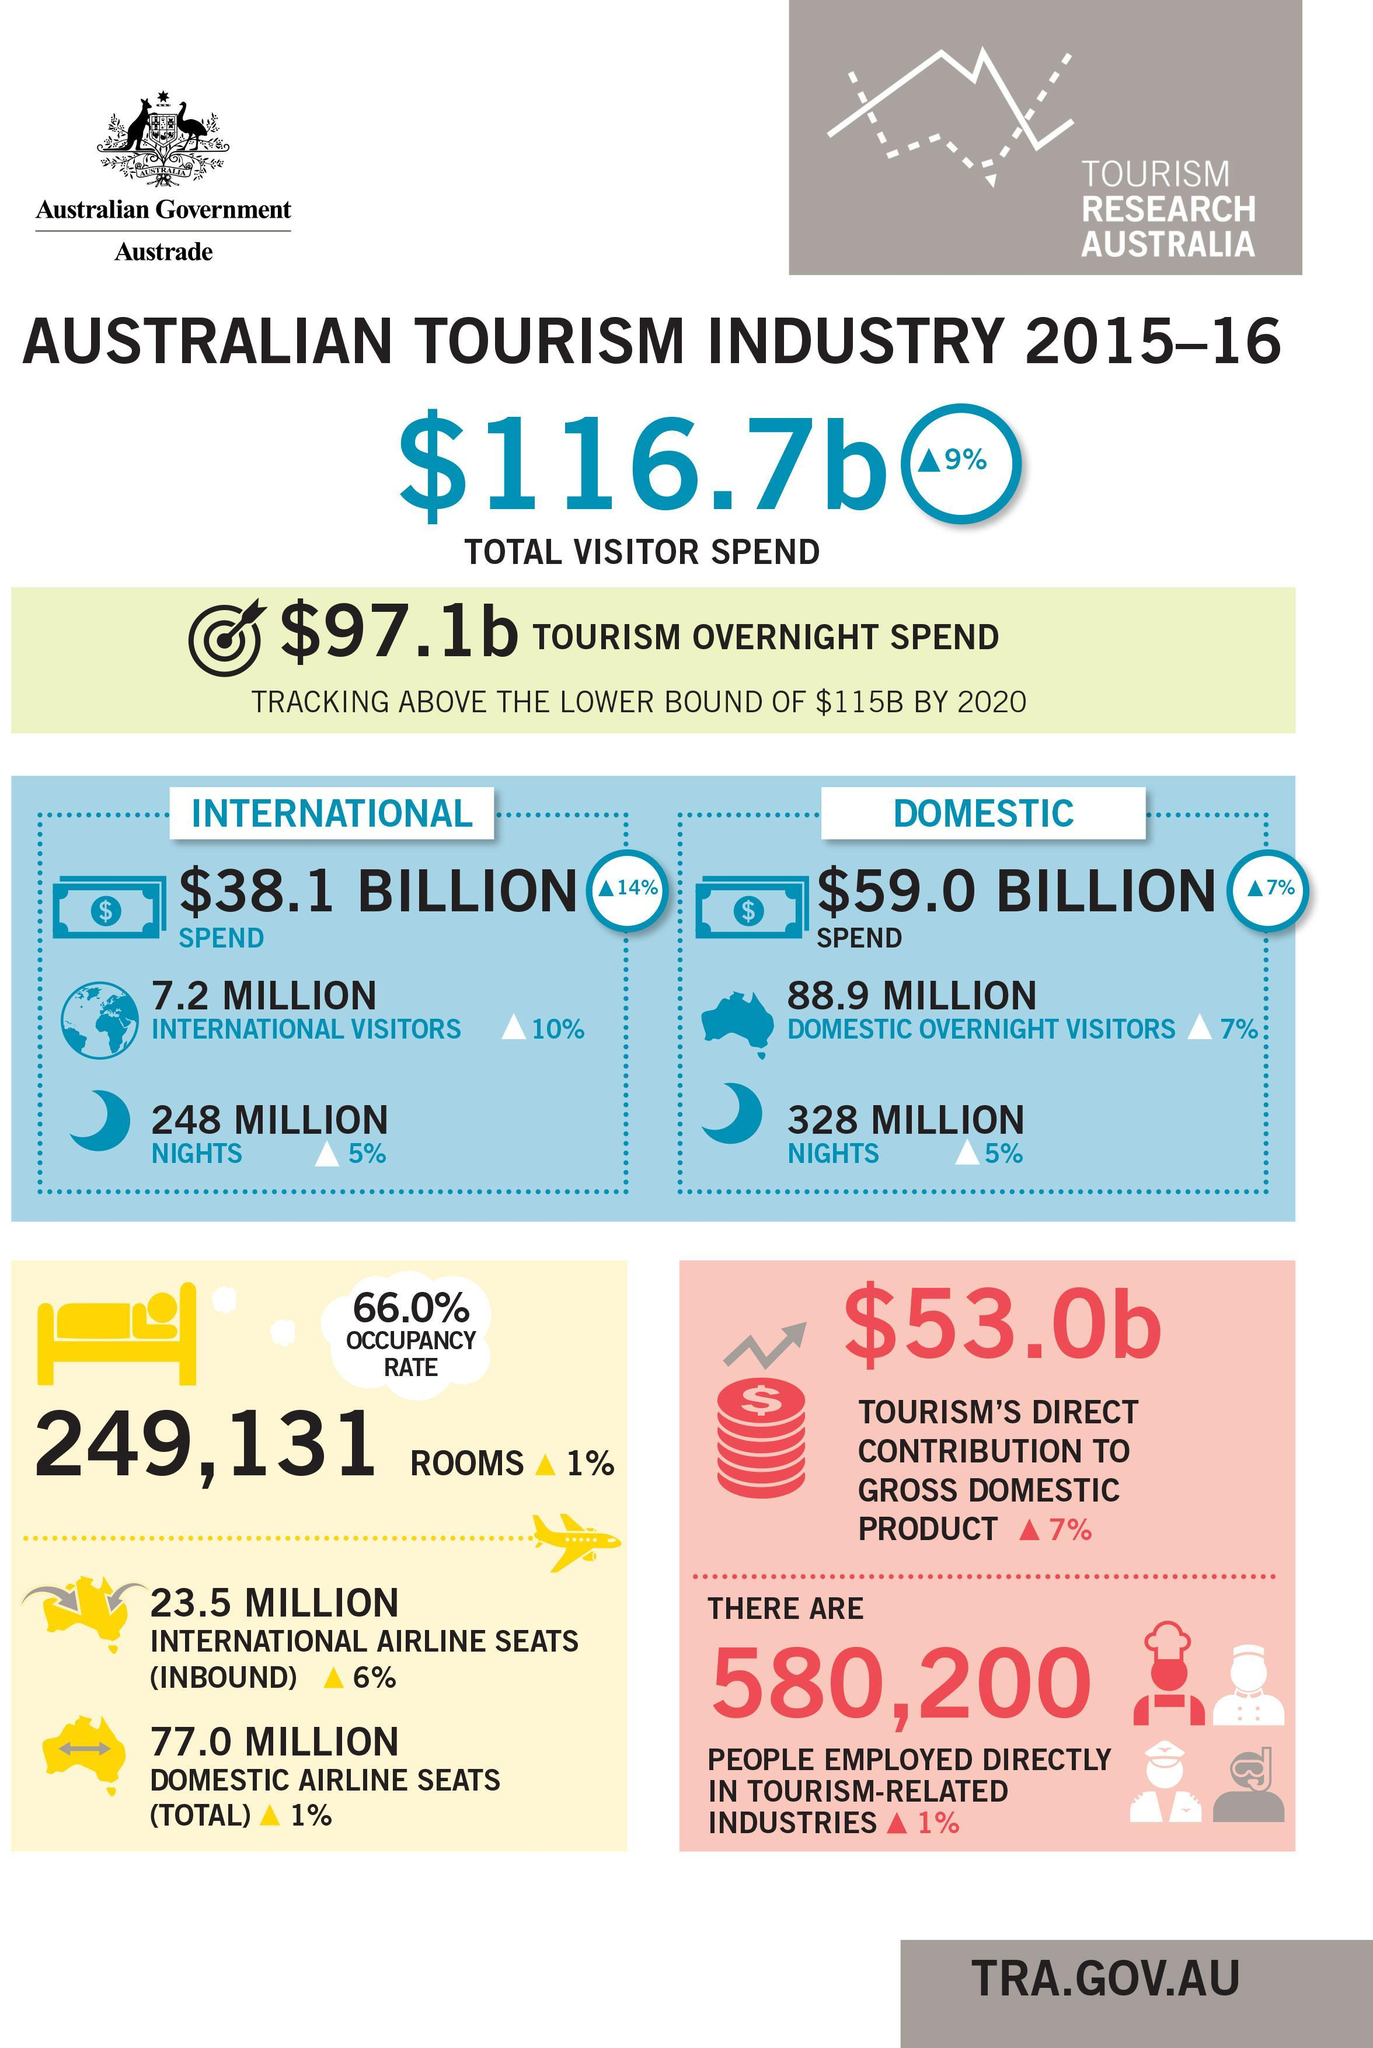What is the amount contributed to GDP by Australian tourism industry  in 2015-16?
Answer the question with a short phrase. $53.0b What is the amount spend on domestic tourism by Australian tourism industry in 2015-16? $59.0 BILLION How many international tourists visited Australia in in 2015-16? 7.2 MILLION How many people were employed directly in tourism-related industries in Australia in 2015-16? 580,200 What is the amount spend on international tourism by Australian tourism industry in 2015-16? $38.1 BILLION 